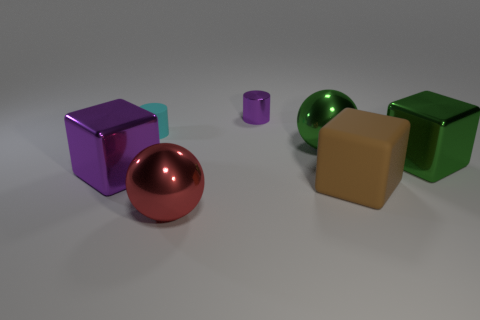Subtract all metal cubes. How many cubes are left? 1 Subtract 1 blocks. How many blocks are left? 2 Subtract all cylinders. How many objects are left? 5 Add 2 big green metallic objects. How many objects exist? 9 Add 7 tiny things. How many tiny things exist? 9 Subtract 0 purple spheres. How many objects are left? 7 Subtract all tiny blue matte balls. Subtract all small cyan matte cylinders. How many objects are left? 6 Add 5 tiny purple cylinders. How many tiny purple cylinders are left? 6 